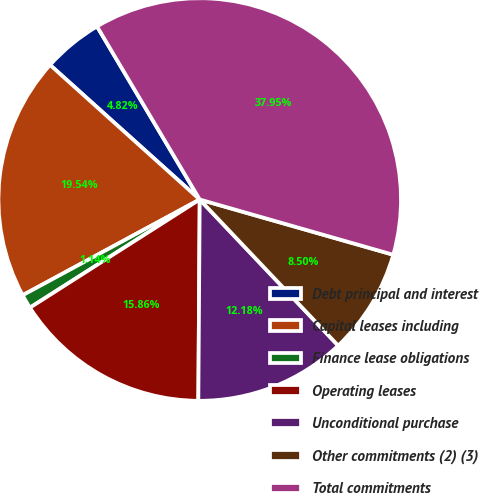Convert chart. <chart><loc_0><loc_0><loc_500><loc_500><pie_chart><fcel>Debt principal and interest<fcel>Capital leases including<fcel>Finance lease obligations<fcel>Operating leases<fcel>Unconditional purchase<fcel>Other commitments (2) (3)<fcel>Total commitments<nl><fcel>4.82%<fcel>19.54%<fcel>1.14%<fcel>15.86%<fcel>12.18%<fcel>8.5%<fcel>37.94%<nl></chart> 